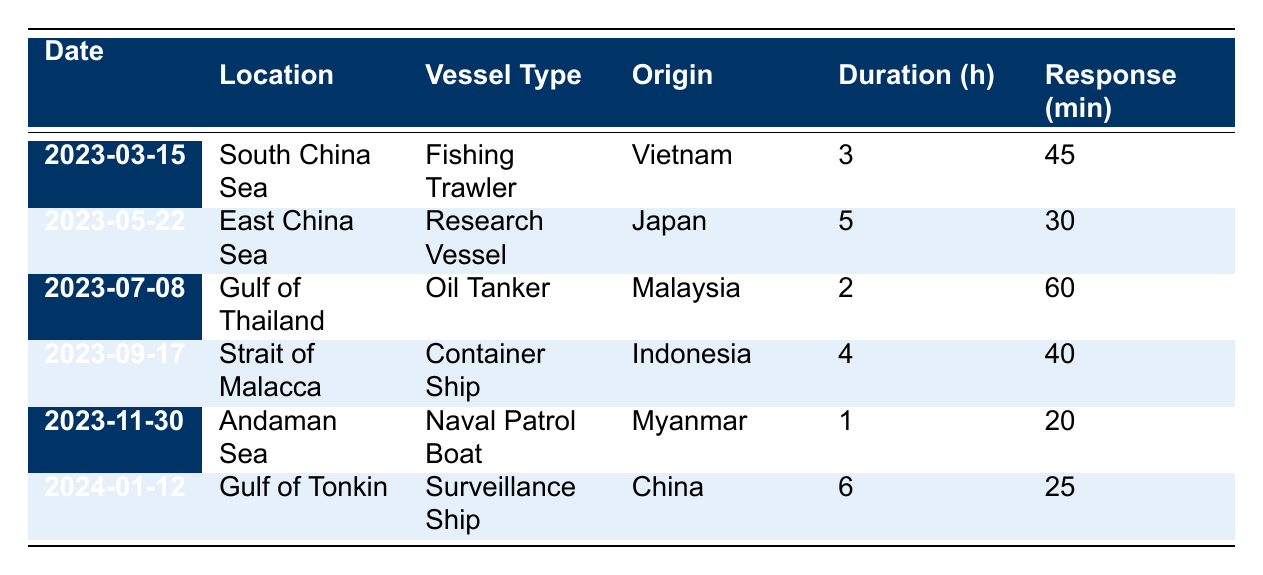What is the date of the first recorded incursion? The first recorded incursion is on the date listed as "2023-03-15." This can be found by looking at the first row of the table.
Answer: 2023-03-15 Which vessel had the longest duration of incursion? The vessel with the longest duration is the "Surveillance Ship" from China, which lasted for 6 hours. This is determined by comparing the duration hours of each incident listed.
Answer: Surveillance Ship How many incursions involved vessels from Malaysia? There is one incursion involving a vessel from Malaysia, which is the "Oil Tanker." This is found by counting the number of entries that list "Malaysia" under the country of origin.
Answer: 1 What was the average response time for all the incidents? To find the average response time, sum the response times: 45 + 30 + 60 + 40 + 20 + 25 = 220 minutes. There are six incidents, so the average is 220/6 = 36.67 minutes.
Answer: 36.67 minutes Is there an incident where the duration was less than two hours? Yes, there is an incident on "2023-11-30" involving a "Naval Patrol Boat" which had a duration of 1 hour. This is confirmed by checking the duration column in the table.
Answer: Yes Which country had the quickest response time? The quickest response time is 20 minutes for the "Naval Patrol Boat" from Myanmar. This is identified by looking at the response time values and finding the minimum.
Answer: Myanmar What is the total duration of all incursions combined? The total duration is calculated as follows: 3 + 5 + 2 + 4 + 1 + 6 = 21 hours. This is done by summing all the duration hours listed in the table.
Answer: 21 hours Which location had an incursion by a Research Vessel? The incursion by a Research Vessel occurred in the "East China Sea" on "2023-05-22." This information can be found by locating the relevant entry in the table.
Answer: East China Sea How many different types of vessels were involved in these incidents? There are five different types of vessels: Fishing Trawler, Research Vessel, Oil Tanker, Container Ship, and Surveillance Ship. Count each unique vessel type listed in the table.
Answer: 5 Was there any incident involving a vessel from Japan? Yes, there was one incident involving a vessel from Japan, which is the "Research Vessel" on "2023-05-22." This is confirmed by locating the relevant entry in the table.
Answer: Yes 